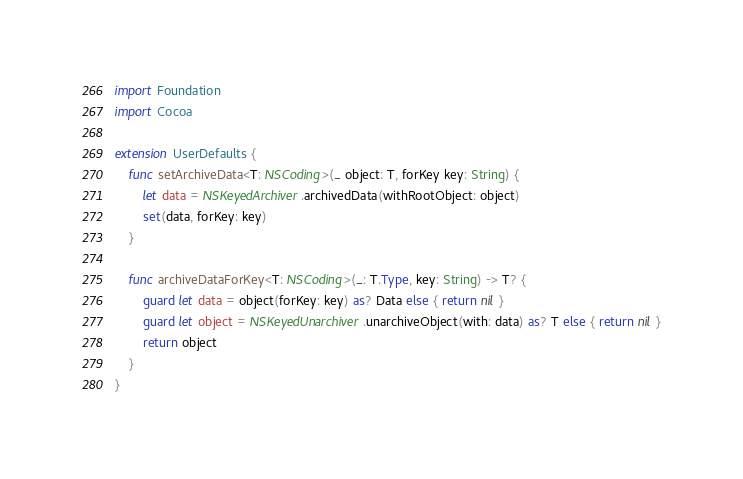Convert code to text. <code><loc_0><loc_0><loc_500><loc_500><_Swift_>import Foundation
import Cocoa

extension UserDefaults {
    func setArchiveData<T: NSCoding>(_ object: T, forKey key: String) {
        let data = NSKeyedArchiver.archivedData(withRootObject: object)
        set(data, forKey: key)
    }

    func archiveDataForKey<T: NSCoding>(_: T.Type, key: String) -> T? {
        guard let data = object(forKey: key) as? Data else { return nil }
        guard let object = NSKeyedUnarchiver.unarchiveObject(with: data) as? T else { return nil }
        return object
    }
}
</code> 